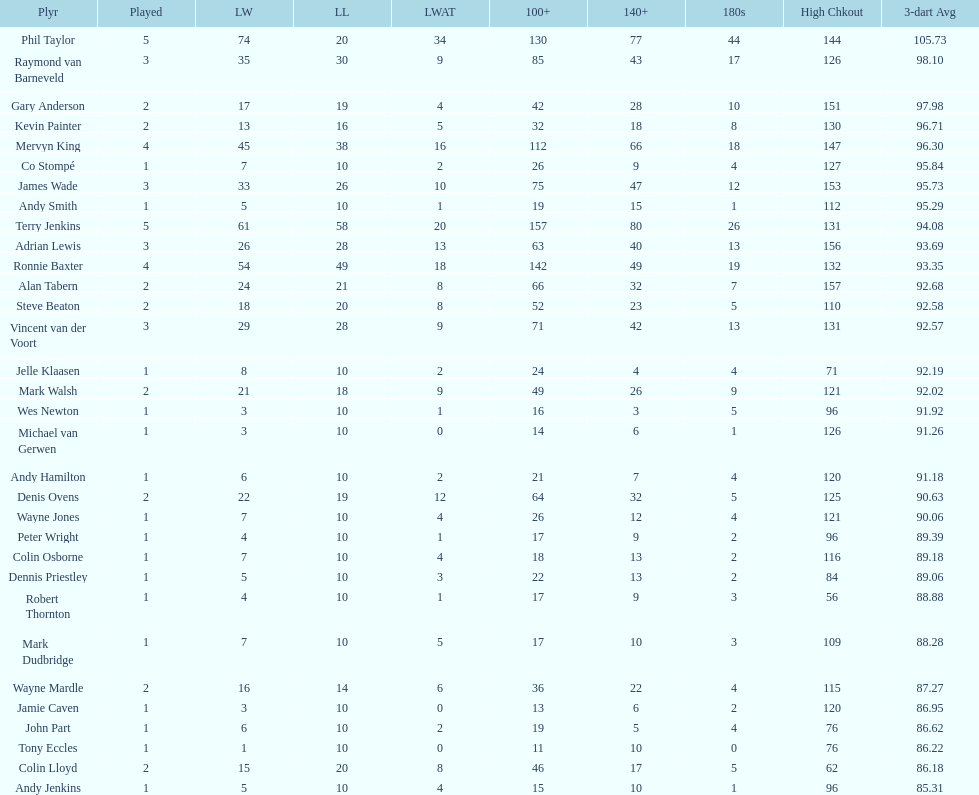What is the name of the next player after mark walsh? Wes Newton. 